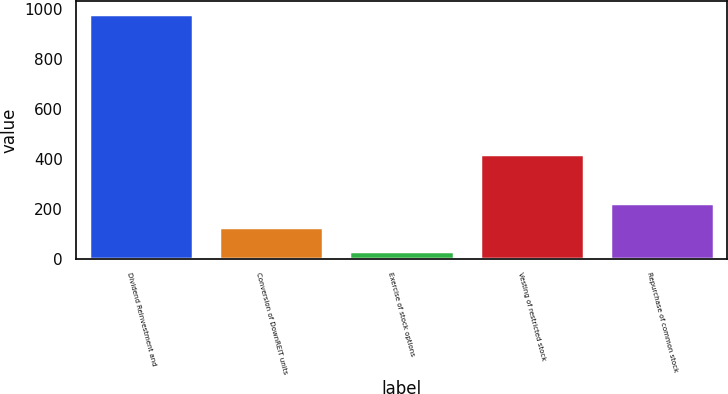<chart> <loc_0><loc_0><loc_500><loc_500><bar_chart><fcel>Dividend Reinvestment and<fcel>Conversion of DownREIT units<fcel>Exercise of stock options<fcel>Vesting of restricted stock<fcel>Repurchase of common stock<nl><fcel>983<fcel>127.1<fcel>32<fcel>419<fcel>222.2<nl></chart> 